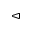Convert formula to latex. <formula><loc_0><loc_0><loc_500><loc_500>\vartriangleleft</formula> 